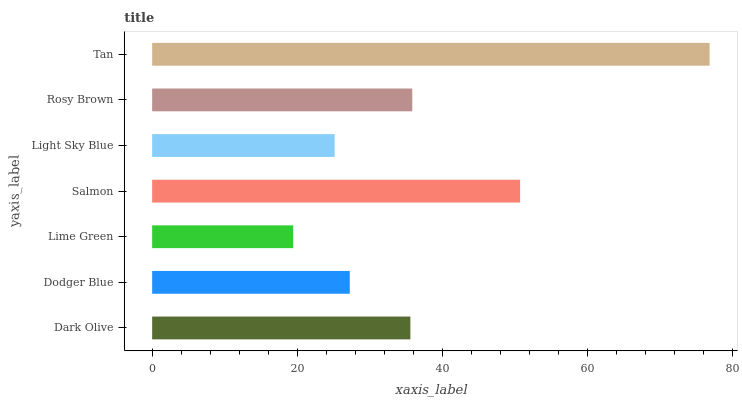Is Lime Green the minimum?
Answer yes or no. Yes. Is Tan the maximum?
Answer yes or no. Yes. Is Dodger Blue the minimum?
Answer yes or no. No. Is Dodger Blue the maximum?
Answer yes or no. No. Is Dark Olive greater than Dodger Blue?
Answer yes or no. Yes. Is Dodger Blue less than Dark Olive?
Answer yes or no. Yes. Is Dodger Blue greater than Dark Olive?
Answer yes or no. No. Is Dark Olive less than Dodger Blue?
Answer yes or no. No. Is Dark Olive the high median?
Answer yes or no. Yes. Is Dark Olive the low median?
Answer yes or no. Yes. Is Light Sky Blue the high median?
Answer yes or no. No. Is Dodger Blue the low median?
Answer yes or no. No. 